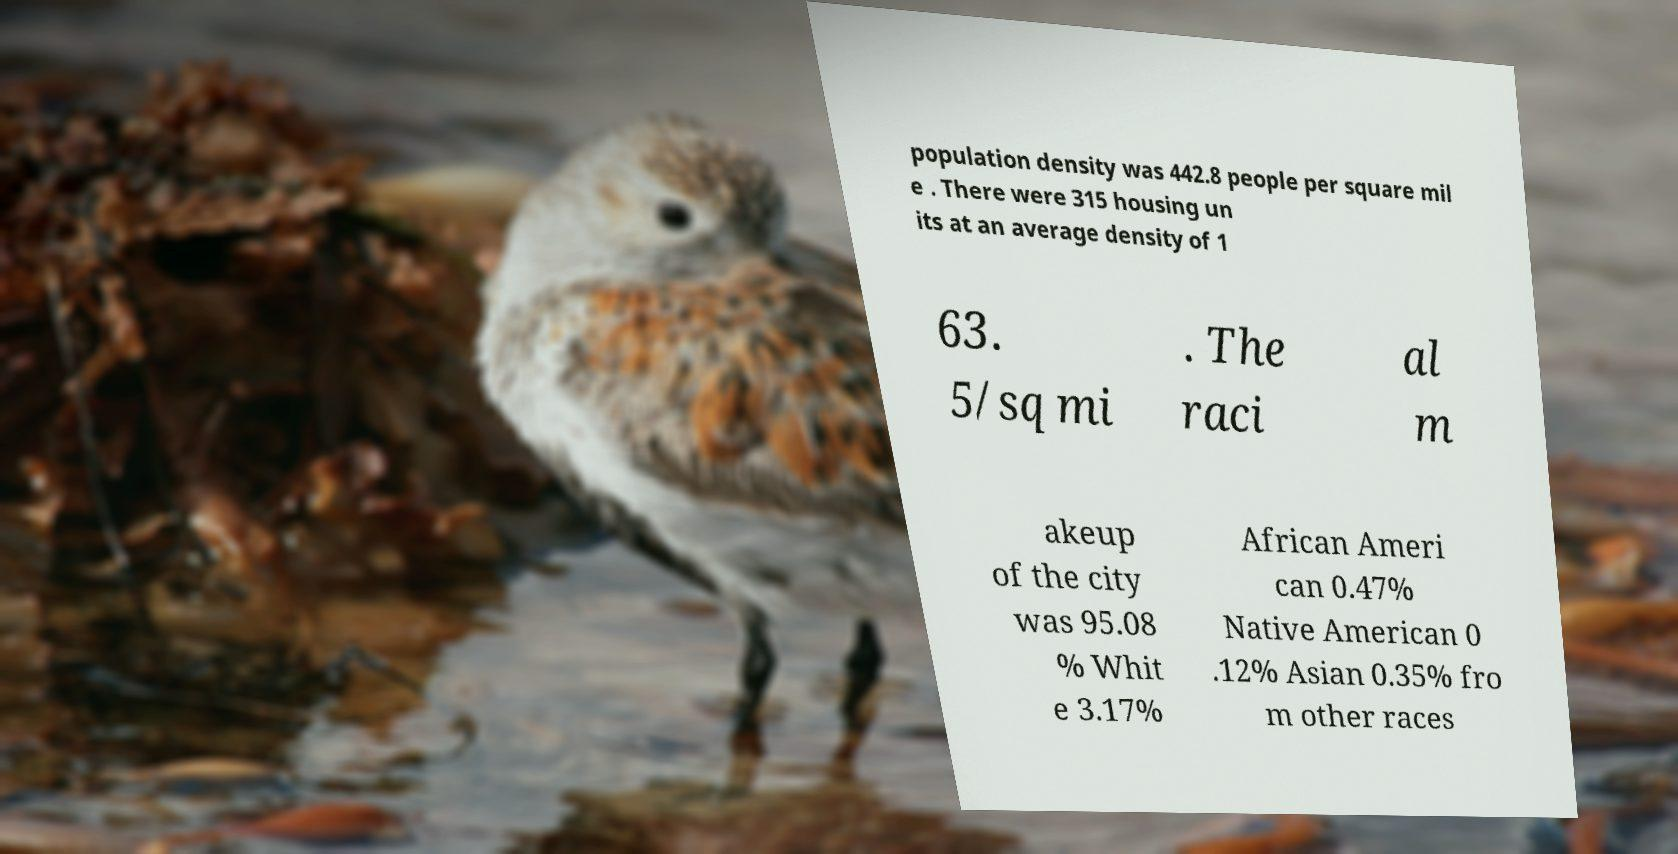Can you accurately transcribe the text from the provided image for me? population density was 442.8 people per square mil e . There were 315 housing un its at an average density of 1 63. 5/sq mi . The raci al m akeup of the city was 95.08 % Whit e 3.17% African Ameri can 0.47% Native American 0 .12% Asian 0.35% fro m other races 